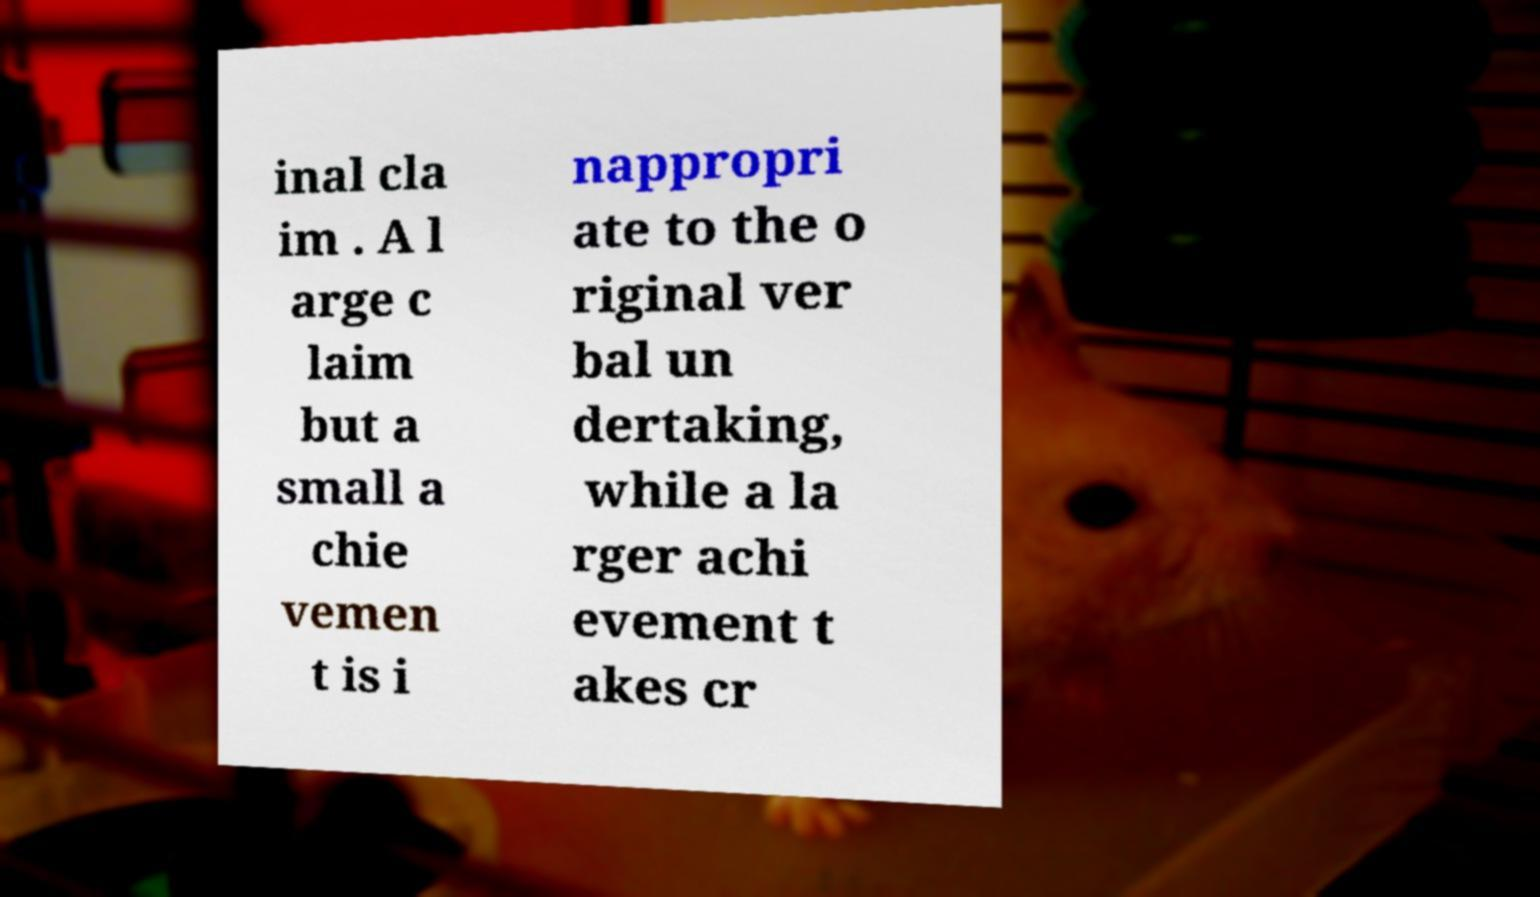There's text embedded in this image that I need extracted. Can you transcribe it verbatim? inal cla im . A l arge c laim but a small a chie vemen t is i nappropri ate to the o riginal ver bal un dertaking, while a la rger achi evement t akes cr 